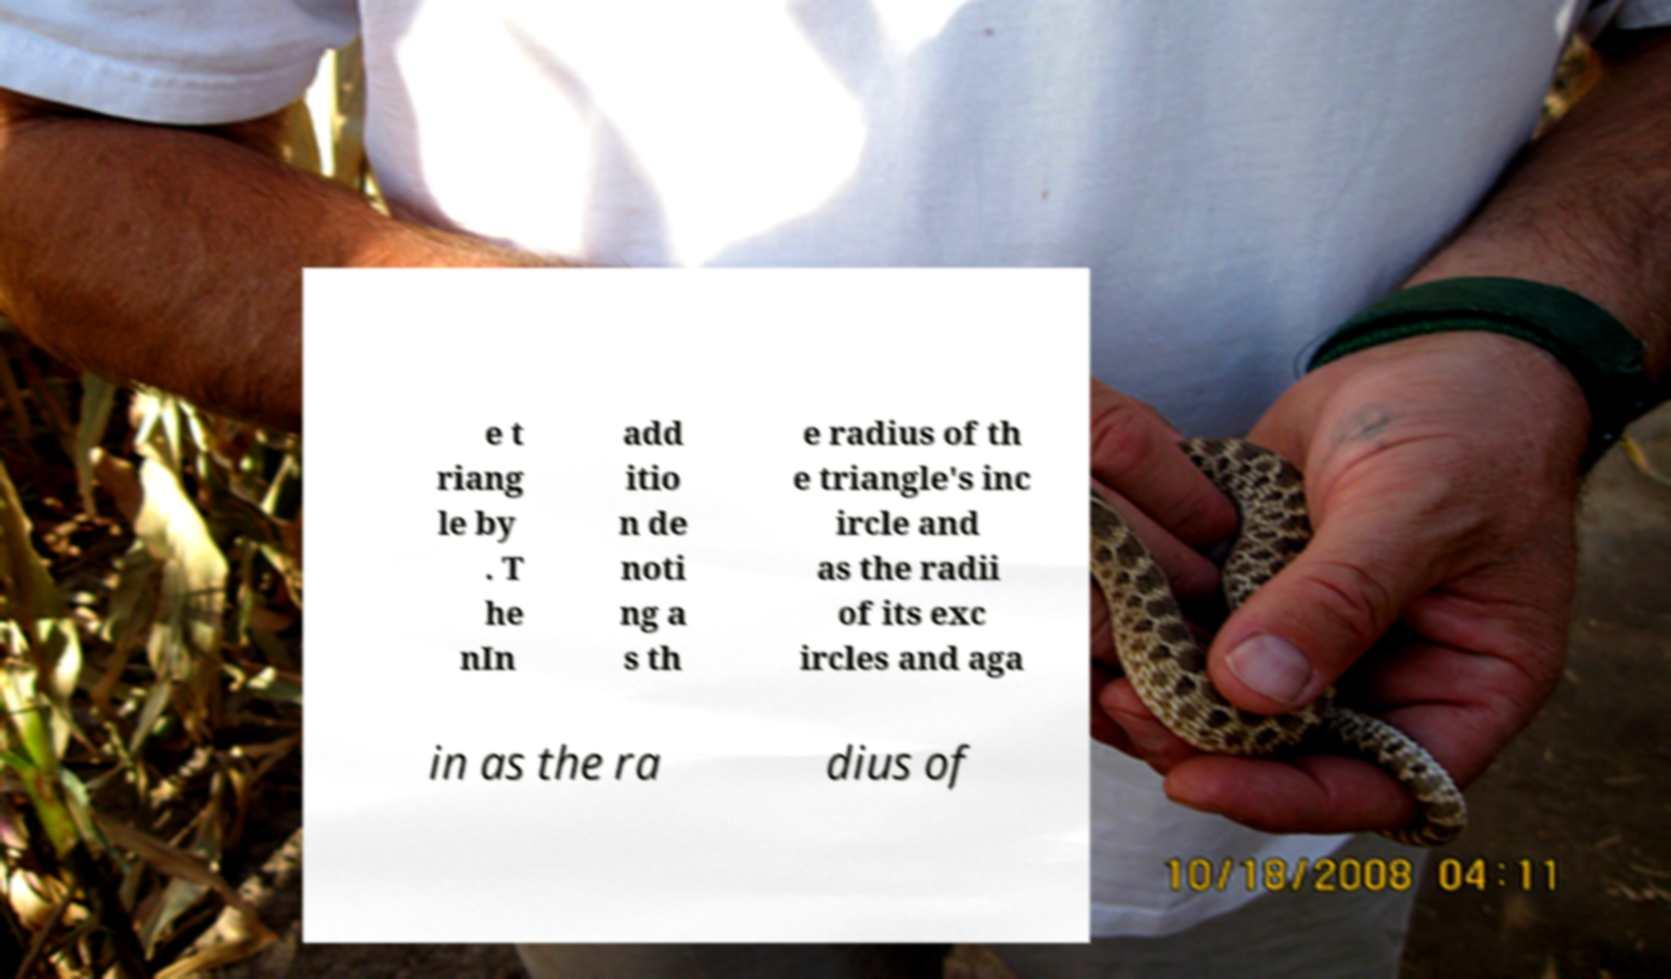Please read and relay the text visible in this image. What does it say? e t riang le by . T he nIn add itio n de noti ng a s th e radius of th e triangle's inc ircle and as the radii of its exc ircles and aga in as the ra dius of 